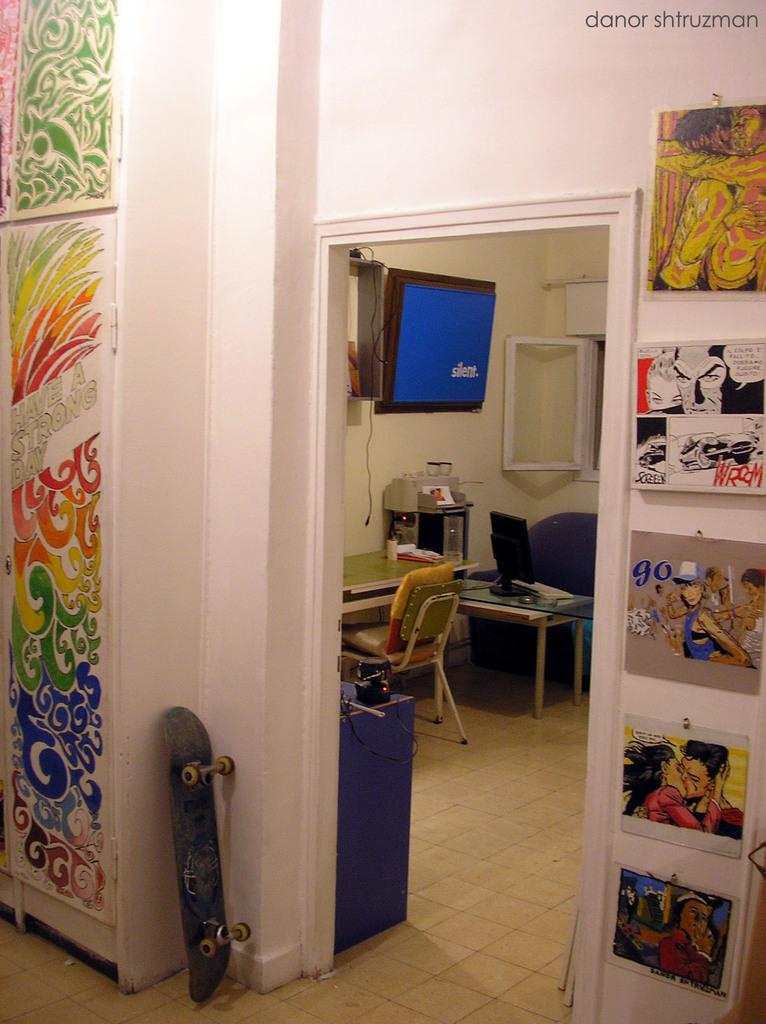What type of structure can be seen in the image? There is a wall in the image. What is the purpose of the scattering board in the image? The scattering board is likely used for playing games or engaging in other activities. What type of furniture is present in the image? There are chairs and tables in the image. How many bones are visible on the wall in the image? There are no bones visible on the wall in the image. What type of sheet is covering the chairs in the image? There are no sheets covering the chairs in the image. 